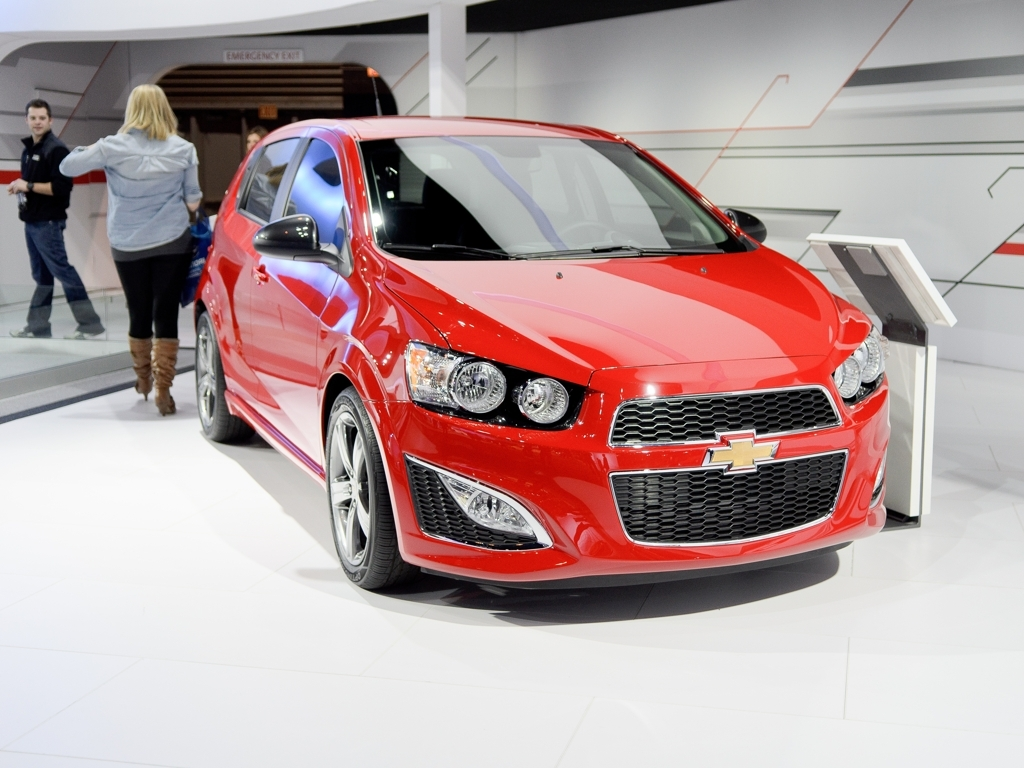What features of this car stand out to you? Several features stand out. Firstly, the vibrant red color catches the eye and is likely to appeal to those who appreciate bold aesthetics. The front fascia is aggressive, with a large grille and angular headlamps. The wheels have a dynamic spoke design that suggests performance, and the sleek exterior lines contribute to an overall impression of speed and agility. How does the design of the car influence its perceived performance? The design elements such as the low and wide stance, aerodynamic lines, and wheel size give the impression of a car built for responsive handling and speed. Even stationary, it seems poised for quick acceleration. The large air intakes in the front bumper could hint at functional cooling for high-performance driving. These design cues collectively suggest that the car's performance is a significant aspect of its overall design philosophy. 